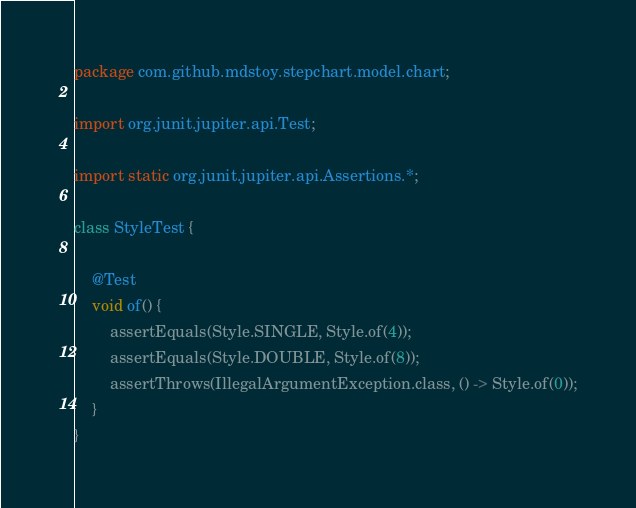Convert code to text. <code><loc_0><loc_0><loc_500><loc_500><_Java_>package com.github.mdstoy.stepchart.model.chart;

import org.junit.jupiter.api.Test;

import static org.junit.jupiter.api.Assertions.*;

class StyleTest {

    @Test
    void of() {
        assertEquals(Style.SINGLE, Style.of(4));
        assertEquals(Style.DOUBLE, Style.of(8));
        assertThrows(IllegalArgumentException.class, () -> Style.of(0));
    }
}</code> 